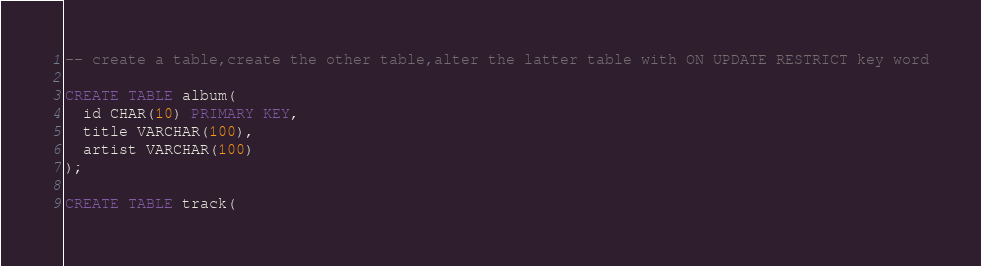<code> <loc_0><loc_0><loc_500><loc_500><_SQL_>-- create a table,create the other table,alter the latter table with ON UPDATE RESTRICT key word

CREATE TABLE album(
  id CHAR(10) PRIMARY KEY,
  title VARCHAR(100),
  artist VARCHAR(100)
);

CREATE TABLE track(</code> 